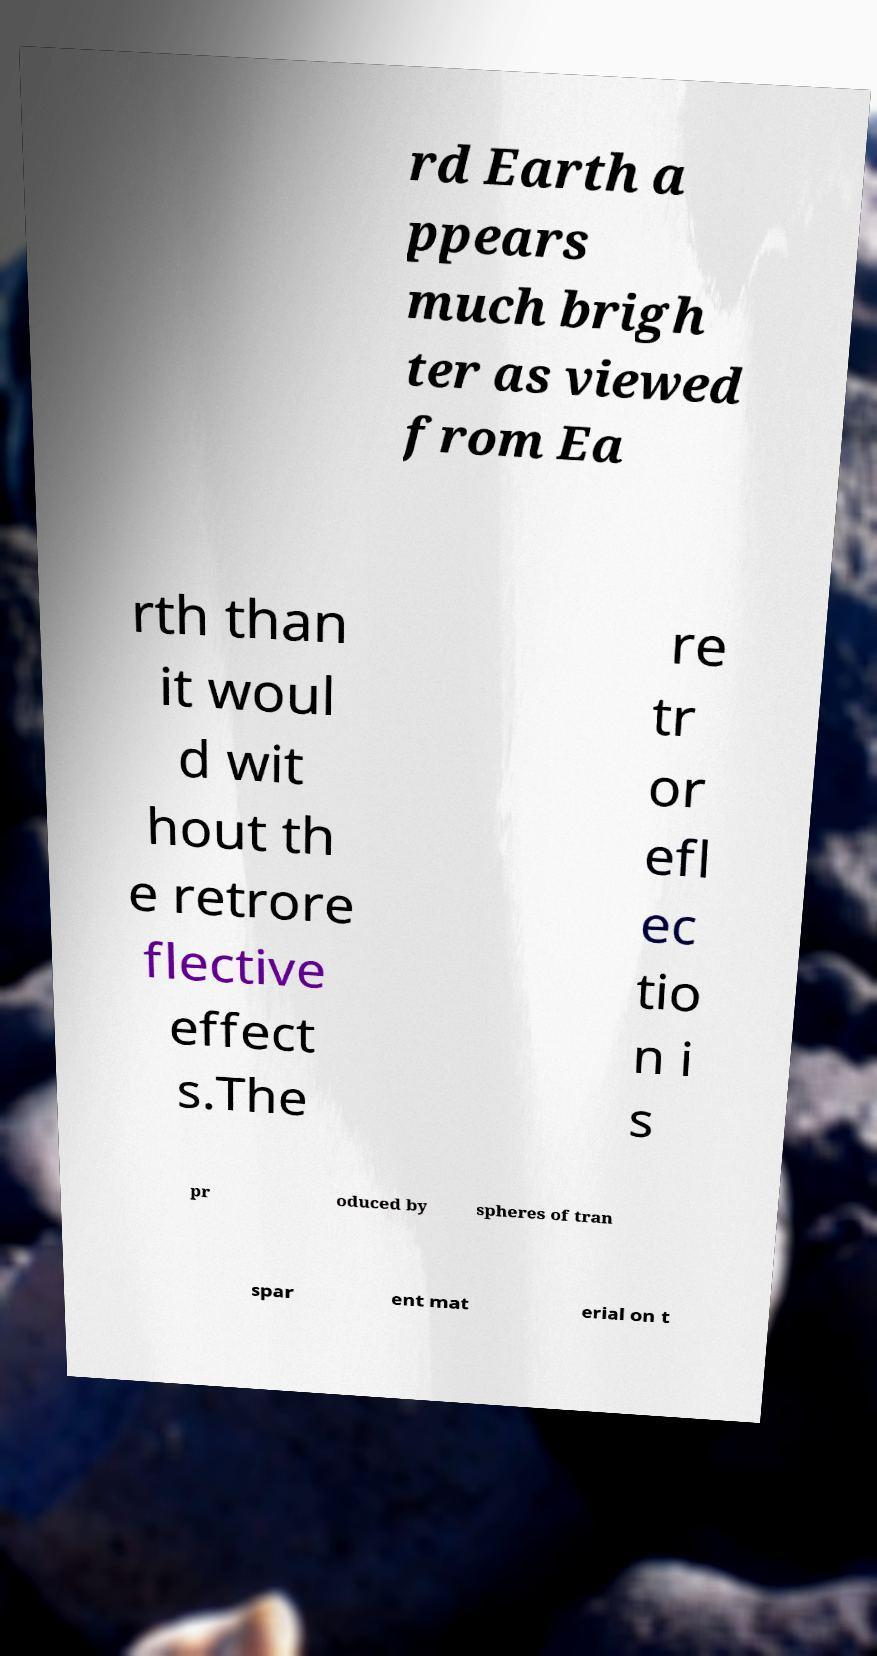Could you extract and type out the text from this image? rd Earth a ppears much brigh ter as viewed from Ea rth than it woul d wit hout th e retrore flective effect s.The re tr or efl ec tio n i s pr oduced by spheres of tran spar ent mat erial on t 